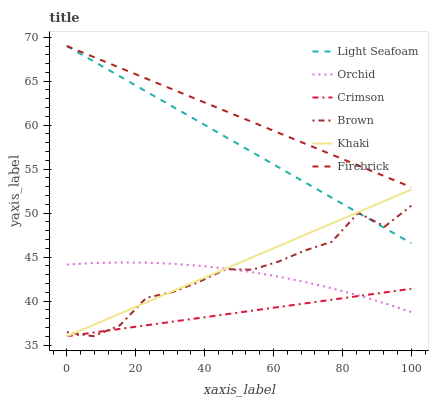Does Crimson have the minimum area under the curve?
Answer yes or no. Yes. Does Firebrick have the maximum area under the curve?
Answer yes or no. Yes. Does Khaki have the minimum area under the curve?
Answer yes or no. No. Does Khaki have the maximum area under the curve?
Answer yes or no. No. Is Crimson the smoothest?
Answer yes or no. Yes. Is Brown the roughest?
Answer yes or no. Yes. Is Khaki the smoothest?
Answer yes or no. No. Is Khaki the roughest?
Answer yes or no. No. Does Brown have the lowest value?
Answer yes or no. Yes. Does Firebrick have the lowest value?
Answer yes or no. No. Does Light Seafoam have the highest value?
Answer yes or no. Yes. Does Khaki have the highest value?
Answer yes or no. No. Is Orchid less than Firebrick?
Answer yes or no. Yes. Is Firebrick greater than Brown?
Answer yes or no. Yes. Does Orchid intersect Crimson?
Answer yes or no. Yes. Is Orchid less than Crimson?
Answer yes or no. No. Is Orchid greater than Crimson?
Answer yes or no. No. Does Orchid intersect Firebrick?
Answer yes or no. No. 